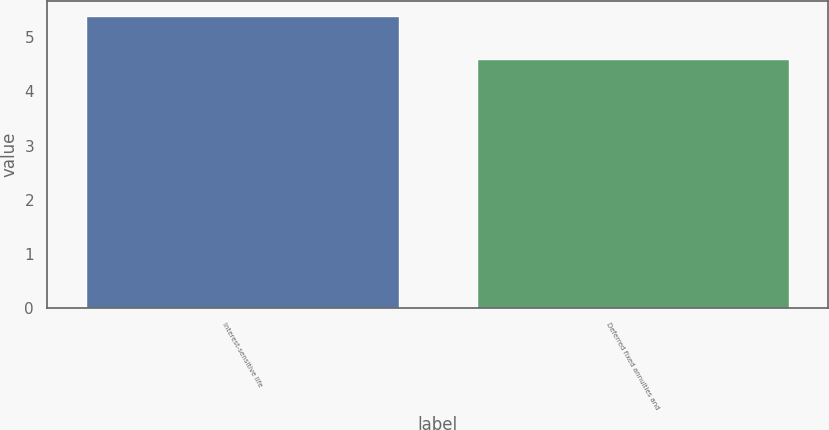Convert chart to OTSL. <chart><loc_0><loc_0><loc_500><loc_500><bar_chart><fcel>Interest-sensitive life<fcel>Deferred fixed annuities and<nl><fcel>5.4<fcel>4.6<nl></chart> 